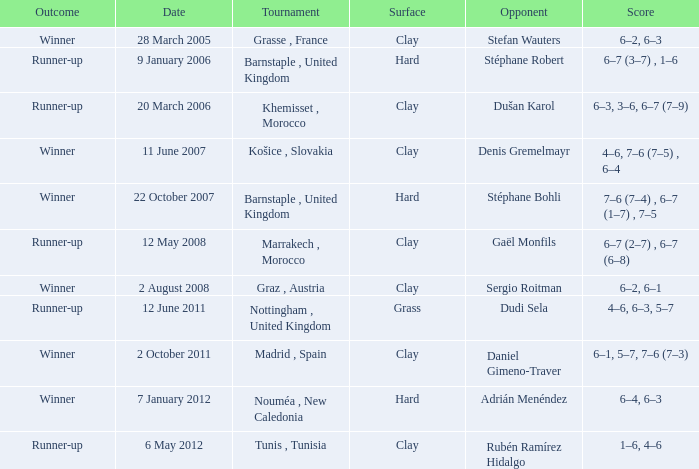What is the surface of the tournament with a runner-up outcome and dudi sela as the opponent? Grass. 